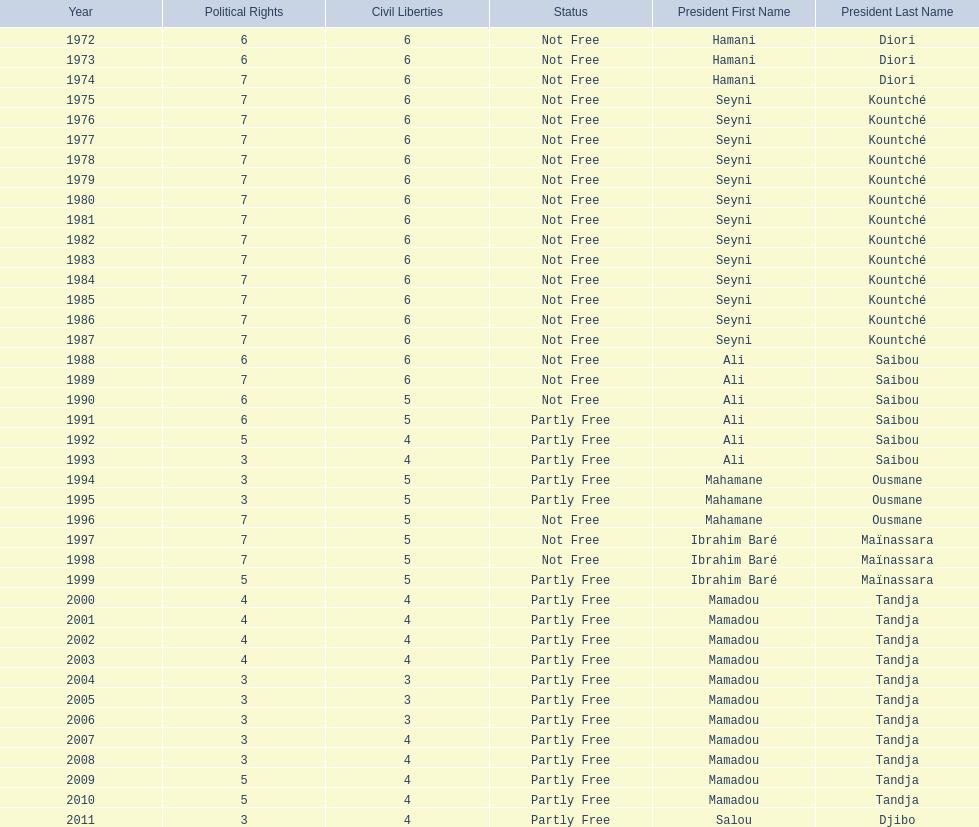How many times was the political rights listed as seven? 18. 